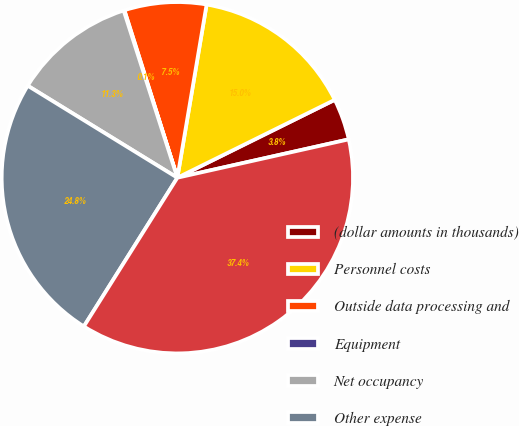<chart> <loc_0><loc_0><loc_500><loc_500><pie_chart><fcel>(dollar amounts in thousands)<fcel>Personnel costs<fcel>Outside data processing and<fcel>Equipment<fcel>Net occupancy<fcel>Other expense<fcel>Total noninterest expense<nl><fcel>3.81%<fcel>15.02%<fcel>7.54%<fcel>0.07%<fcel>11.28%<fcel>24.84%<fcel>37.44%<nl></chart> 